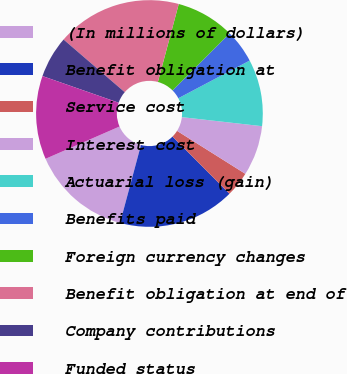<chart> <loc_0><loc_0><loc_500><loc_500><pie_chart><fcel>(In millions of dollars)<fcel>Benefit obligation at<fcel>Service cost<fcel>Interest cost<fcel>Actuarial loss (gain)<fcel>Benefits paid<fcel>Foreign currency changes<fcel>Benefit obligation at end of<fcel>Company contributions<fcel>Funded status<nl><fcel>14.28%<fcel>16.66%<fcel>3.58%<fcel>7.15%<fcel>9.52%<fcel>4.77%<fcel>8.34%<fcel>17.85%<fcel>5.96%<fcel>11.9%<nl></chart> 